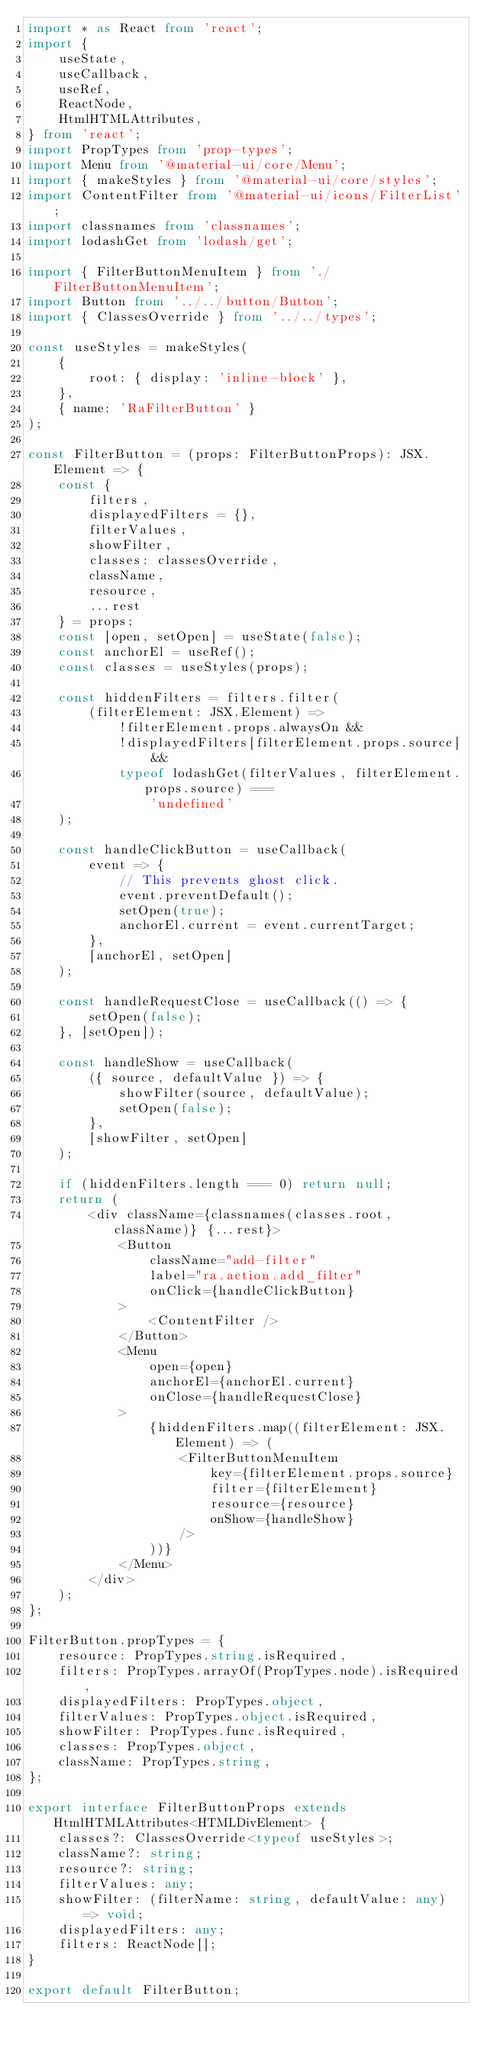<code> <loc_0><loc_0><loc_500><loc_500><_TypeScript_>import * as React from 'react';
import {
    useState,
    useCallback,
    useRef,
    ReactNode,
    HtmlHTMLAttributes,
} from 'react';
import PropTypes from 'prop-types';
import Menu from '@material-ui/core/Menu';
import { makeStyles } from '@material-ui/core/styles';
import ContentFilter from '@material-ui/icons/FilterList';
import classnames from 'classnames';
import lodashGet from 'lodash/get';

import { FilterButtonMenuItem } from './FilterButtonMenuItem';
import Button from '../../button/Button';
import { ClassesOverride } from '../../types';

const useStyles = makeStyles(
    {
        root: { display: 'inline-block' },
    },
    { name: 'RaFilterButton' }
);

const FilterButton = (props: FilterButtonProps): JSX.Element => {
    const {
        filters,
        displayedFilters = {},
        filterValues,
        showFilter,
        classes: classesOverride,
        className,
        resource,
        ...rest
    } = props;
    const [open, setOpen] = useState(false);
    const anchorEl = useRef();
    const classes = useStyles(props);

    const hiddenFilters = filters.filter(
        (filterElement: JSX.Element) =>
            !filterElement.props.alwaysOn &&
            !displayedFilters[filterElement.props.source] &&
            typeof lodashGet(filterValues, filterElement.props.source) ===
                'undefined'
    );

    const handleClickButton = useCallback(
        event => {
            // This prevents ghost click.
            event.preventDefault();
            setOpen(true);
            anchorEl.current = event.currentTarget;
        },
        [anchorEl, setOpen]
    );

    const handleRequestClose = useCallback(() => {
        setOpen(false);
    }, [setOpen]);

    const handleShow = useCallback(
        ({ source, defaultValue }) => {
            showFilter(source, defaultValue);
            setOpen(false);
        },
        [showFilter, setOpen]
    );

    if (hiddenFilters.length === 0) return null;
    return (
        <div className={classnames(classes.root, className)} {...rest}>
            <Button
                className="add-filter"
                label="ra.action.add_filter"
                onClick={handleClickButton}
            >
                <ContentFilter />
            </Button>
            <Menu
                open={open}
                anchorEl={anchorEl.current}
                onClose={handleRequestClose}
            >
                {hiddenFilters.map((filterElement: JSX.Element) => (
                    <FilterButtonMenuItem
                        key={filterElement.props.source}
                        filter={filterElement}
                        resource={resource}
                        onShow={handleShow}
                    />
                ))}
            </Menu>
        </div>
    );
};

FilterButton.propTypes = {
    resource: PropTypes.string.isRequired,
    filters: PropTypes.arrayOf(PropTypes.node).isRequired,
    displayedFilters: PropTypes.object,
    filterValues: PropTypes.object.isRequired,
    showFilter: PropTypes.func.isRequired,
    classes: PropTypes.object,
    className: PropTypes.string,
};

export interface FilterButtonProps extends HtmlHTMLAttributes<HTMLDivElement> {
    classes?: ClassesOverride<typeof useStyles>;
    className?: string;
    resource?: string;
    filterValues: any;
    showFilter: (filterName: string, defaultValue: any) => void;
    displayedFilters: any;
    filters: ReactNode[];
}

export default FilterButton;
</code> 